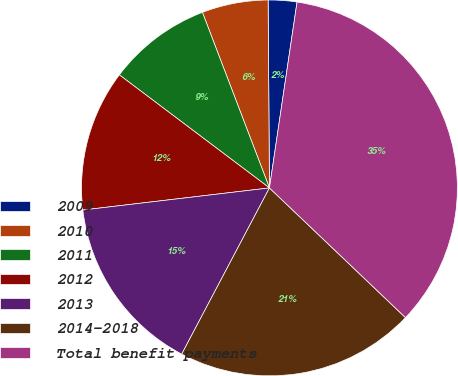Convert chart to OTSL. <chart><loc_0><loc_0><loc_500><loc_500><pie_chart><fcel>2009<fcel>2010<fcel>2011<fcel>2012<fcel>2013<fcel>2014-2018<fcel>Total benefit payments<nl><fcel>2.46%<fcel>5.69%<fcel>8.92%<fcel>12.15%<fcel>15.39%<fcel>20.61%<fcel>34.77%<nl></chart> 